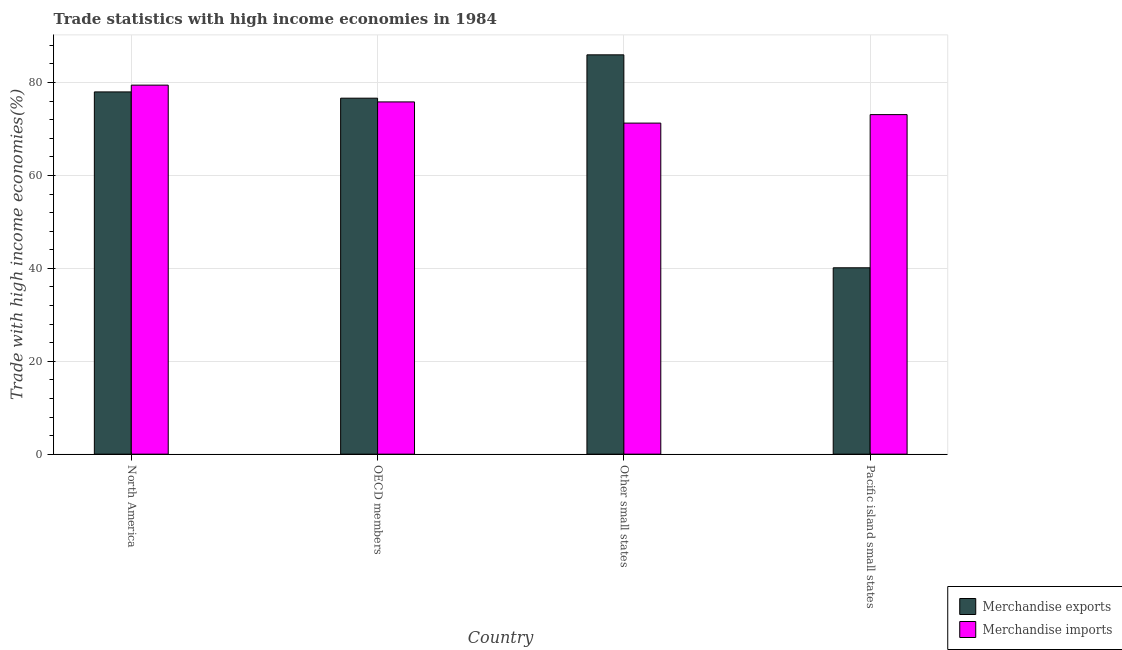Are the number of bars per tick equal to the number of legend labels?
Provide a succinct answer. Yes. Are the number of bars on each tick of the X-axis equal?
Ensure brevity in your answer.  Yes. What is the label of the 4th group of bars from the left?
Offer a terse response. Pacific island small states. What is the merchandise imports in Other small states?
Ensure brevity in your answer.  71.27. Across all countries, what is the maximum merchandise exports?
Provide a succinct answer. 85.97. Across all countries, what is the minimum merchandise imports?
Provide a short and direct response. 71.27. In which country was the merchandise exports maximum?
Your answer should be very brief. Other small states. In which country was the merchandise exports minimum?
Make the answer very short. Pacific island small states. What is the total merchandise exports in the graph?
Keep it short and to the point. 280.71. What is the difference between the merchandise exports in North America and that in Other small states?
Give a very brief answer. -7.98. What is the difference between the merchandise exports in North America and the merchandise imports in Other small states?
Give a very brief answer. 6.72. What is the average merchandise imports per country?
Offer a terse response. 74.91. What is the difference between the merchandise imports and merchandise exports in Other small states?
Ensure brevity in your answer.  -14.7. What is the ratio of the merchandise imports in North America to that in Other small states?
Give a very brief answer. 1.11. Is the difference between the merchandise exports in OECD members and Other small states greater than the difference between the merchandise imports in OECD members and Other small states?
Offer a terse response. No. What is the difference between the highest and the second highest merchandise exports?
Provide a succinct answer. 7.98. What is the difference between the highest and the lowest merchandise exports?
Ensure brevity in your answer.  45.84. In how many countries, is the merchandise imports greater than the average merchandise imports taken over all countries?
Give a very brief answer. 2. Is the sum of the merchandise exports in North America and Other small states greater than the maximum merchandise imports across all countries?
Ensure brevity in your answer.  Yes. What does the 1st bar from the right in North America represents?
Keep it short and to the point. Merchandise imports. How many bars are there?
Make the answer very short. 8. How many countries are there in the graph?
Make the answer very short. 4. What is the difference between two consecutive major ticks on the Y-axis?
Make the answer very short. 20. Does the graph contain any zero values?
Make the answer very short. No. How many legend labels are there?
Your answer should be compact. 2. How are the legend labels stacked?
Your response must be concise. Vertical. What is the title of the graph?
Give a very brief answer. Trade statistics with high income economies in 1984. Does "Commercial service exports" appear as one of the legend labels in the graph?
Provide a short and direct response. No. What is the label or title of the X-axis?
Your response must be concise. Country. What is the label or title of the Y-axis?
Keep it short and to the point. Trade with high income economies(%). What is the Trade with high income economies(%) in Merchandise exports in North America?
Your response must be concise. 77.98. What is the Trade with high income economies(%) in Merchandise imports in North America?
Provide a short and direct response. 79.44. What is the Trade with high income economies(%) in Merchandise exports in OECD members?
Make the answer very short. 76.63. What is the Trade with high income economies(%) in Merchandise imports in OECD members?
Keep it short and to the point. 75.83. What is the Trade with high income economies(%) of Merchandise exports in Other small states?
Provide a short and direct response. 85.97. What is the Trade with high income economies(%) of Merchandise imports in Other small states?
Ensure brevity in your answer.  71.27. What is the Trade with high income economies(%) in Merchandise exports in Pacific island small states?
Offer a terse response. 40.12. What is the Trade with high income economies(%) in Merchandise imports in Pacific island small states?
Ensure brevity in your answer.  73.1. Across all countries, what is the maximum Trade with high income economies(%) in Merchandise exports?
Your answer should be compact. 85.97. Across all countries, what is the maximum Trade with high income economies(%) of Merchandise imports?
Your answer should be compact. 79.44. Across all countries, what is the minimum Trade with high income economies(%) in Merchandise exports?
Offer a terse response. 40.12. Across all countries, what is the minimum Trade with high income economies(%) of Merchandise imports?
Your answer should be compact. 71.27. What is the total Trade with high income economies(%) in Merchandise exports in the graph?
Provide a short and direct response. 280.71. What is the total Trade with high income economies(%) in Merchandise imports in the graph?
Your answer should be very brief. 299.64. What is the difference between the Trade with high income economies(%) of Merchandise exports in North America and that in OECD members?
Give a very brief answer. 1.35. What is the difference between the Trade with high income economies(%) of Merchandise imports in North America and that in OECD members?
Your response must be concise. 3.61. What is the difference between the Trade with high income economies(%) in Merchandise exports in North America and that in Other small states?
Make the answer very short. -7.98. What is the difference between the Trade with high income economies(%) in Merchandise imports in North America and that in Other small states?
Your answer should be very brief. 8.18. What is the difference between the Trade with high income economies(%) of Merchandise exports in North America and that in Pacific island small states?
Ensure brevity in your answer.  37.86. What is the difference between the Trade with high income economies(%) of Merchandise imports in North America and that in Pacific island small states?
Give a very brief answer. 6.35. What is the difference between the Trade with high income economies(%) of Merchandise exports in OECD members and that in Other small states?
Offer a terse response. -9.33. What is the difference between the Trade with high income economies(%) in Merchandise imports in OECD members and that in Other small states?
Ensure brevity in your answer.  4.56. What is the difference between the Trade with high income economies(%) of Merchandise exports in OECD members and that in Pacific island small states?
Your response must be concise. 36.51. What is the difference between the Trade with high income economies(%) in Merchandise imports in OECD members and that in Pacific island small states?
Provide a succinct answer. 2.73. What is the difference between the Trade with high income economies(%) of Merchandise exports in Other small states and that in Pacific island small states?
Make the answer very short. 45.84. What is the difference between the Trade with high income economies(%) of Merchandise imports in Other small states and that in Pacific island small states?
Keep it short and to the point. -1.83. What is the difference between the Trade with high income economies(%) of Merchandise exports in North America and the Trade with high income economies(%) of Merchandise imports in OECD members?
Offer a terse response. 2.15. What is the difference between the Trade with high income economies(%) in Merchandise exports in North America and the Trade with high income economies(%) in Merchandise imports in Other small states?
Ensure brevity in your answer.  6.72. What is the difference between the Trade with high income economies(%) in Merchandise exports in North America and the Trade with high income economies(%) in Merchandise imports in Pacific island small states?
Your answer should be very brief. 4.89. What is the difference between the Trade with high income economies(%) of Merchandise exports in OECD members and the Trade with high income economies(%) of Merchandise imports in Other small states?
Your answer should be compact. 5.37. What is the difference between the Trade with high income economies(%) of Merchandise exports in OECD members and the Trade with high income economies(%) of Merchandise imports in Pacific island small states?
Offer a terse response. 3.54. What is the difference between the Trade with high income economies(%) in Merchandise exports in Other small states and the Trade with high income economies(%) in Merchandise imports in Pacific island small states?
Provide a short and direct response. 12.87. What is the average Trade with high income economies(%) of Merchandise exports per country?
Provide a short and direct response. 70.18. What is the average Trade with high income economies(%) in Merchandise imports per country?
Make the answer very short. 74.91. What is the difference between the Trade with high income economies(%) in Merchandise exports and Trade with high income economies(%) in Merchandise imports in North America?
Make the answer very short. -1.46. What is the difference between the Trade with high income economies(%) of Merchandise exports and Trade with high income economies(%) of Merchandise imports in OECD members?
Ensure brevity in your answer.  0.8. What is the difference between the Trade with high income economies(%) of Merchandise exports and Trade with high income economies(%) of Merchandise imports in Other small states?
Make the answer very short. 14.7. What is the difference between the Trade with high income economies(%) of Merchandise exports and Trade with high income economies(%) of Merchandise imports in Pacific island small states?
Provide a succinct answer. -32.98. What is the ratio of the Trade with high income economies(%) in Merchandise exports in North America to that in OECD members?
Your answer should be very brief. 1.02. What is the ratio of the Trade with high income economies(%) of Merchandise imports in North America to that in OECD members?
Make the answer very short. 1.05. What is the ratio of the Trade with high income economies(%) in Merchandise exports in North America to that in Other small states?
Keep it short and to the point. 0.91. What is the ratio of the Trade with high income economies(%) of Merchandise imports in North America to that in Other small states?
Your answer should be very brief. 1.11. What is the ratio of the Trade with high income economies(%) of Merchandise exports in North America to that in Pacific island small states?
Ensure brevity in your answer.  1.94. What is the ratio of the Trade with high income economies(%) in Merchandise imports in North America to that in Pacific island small states?
Your answer should be very brief. 1.09. What is the ratio of the Trade with high income economies(%) in Merchandise exports in OECD members to that in Other small states?
Keep it short and to the point. 0.89. What is the ratio of the Trade with high income economies(%) in Merchandise imports in OECD members to that in Other small states?
Your answer should be very brief. 1.06. What is the ratio of the Trade with high income economies(%) in Merchandise exports in OECD members to that in Pacific island small states?
Provide a short and direct response. 1.91. What is the ratio of the Trade with high income economies(%) of Merchandise imports in OECD members to that in Pacific island small states?
Give a very brief answer. 1.04. What is the ratio of the Trade with high income economies(%) of Merchandise exports in Other small states to that in Pacific island small states?
Ensure brevity in your answer.  2.14. What is the difference between the highest and the second highest Trade with high income economies(%) of Merchandise exports?
Keep it short and to the point. 7.98. What is the difference between the highest and the second highest Trade with high income economies(%) of Merchandise imports?
Make the answer very short. 3.61. What is the difference between the highest and the lowest Trade with high income economies(%) of Merchandise exports?
Make the answer very short. 45.84. What is the difference between the highest and the lowest Trade with high income economies(%) of Merchandise imports?
Offer a terse response. 8.18. 